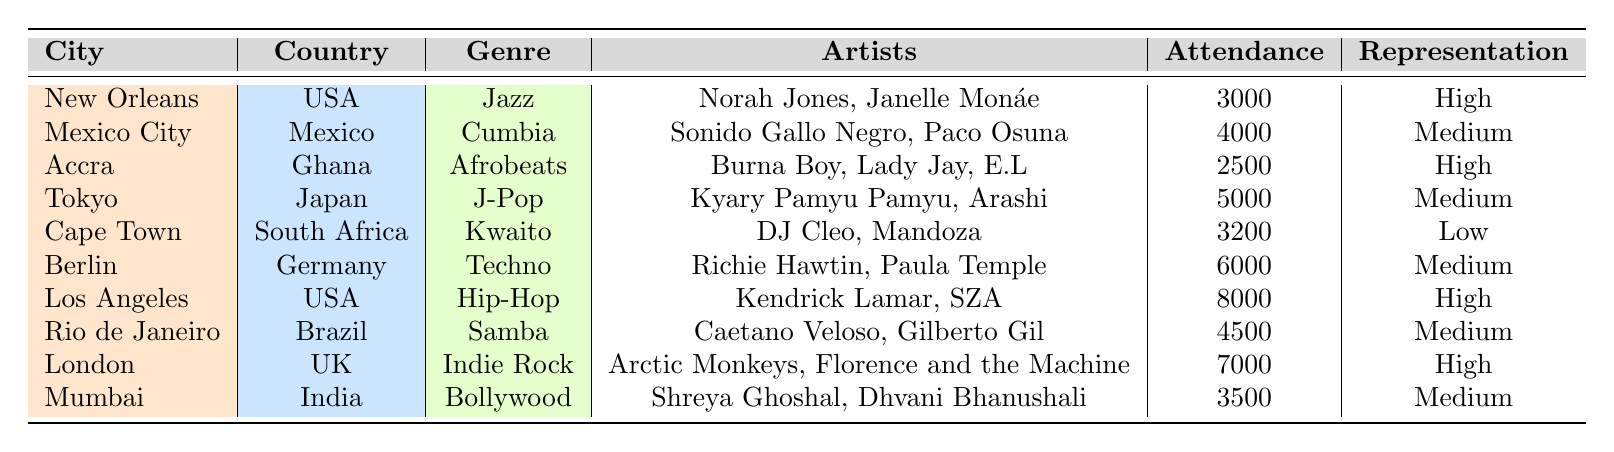What genre had the highest number of events in the table? The table lists a single event for each genre, therefore no genre has more than one event. Hence, all genres are equally represented with one event each.
Answer: None Which city has the highest attendance at a live music event? By examining the attendance figures in the table, Los Angeles has 8000 attendees, which is the highest compared to other cities.
Answer: Los Angeles Are there any events with low representation? The table shows that Cape Town has a low representation indicated in the "Representation" column.
Answer: Yes What is the average attendance of events categorized as high representation? There are three events with high representation: New Orleans (3000), Accra (2500), and Los Angeles (8000). Summing the attendances gives 3000 + 2500 + 8000 = 13500, and dividing by 3 gives an average attendance of 4500.
Answer: 4500 Are there any J-Pop events that are categorized as medium representation? The table lists a J-Pop event in Tokyo, which has medium representation. Therefore, the statement is true.
Answer: Yes Which country has the most artists listed in the events? By checking the number of artists per event, Ghana has three listed artists (Burna Boy, Lady Jay, E.L), while other countries have fewer. Since no other event has more, Ghana has the most artists.
Answer: Ghana What is the total attendance for all events held in the USA? The events in the USA are from New Orleans (3000) and Los Angeles (8000). Adding these gives a total attendance of 3000 + 8000 = 11000.
Answer: 11000 Do any events feature artists from more than one genre? Each event listed in the table focuses exclusively on one genre and does not feature multiple genres within the same event.
Answer: No What is the representation level of the event in Berlin? The representation for the event in Berlin is indicated as medium in the table.
Answer: Medium 